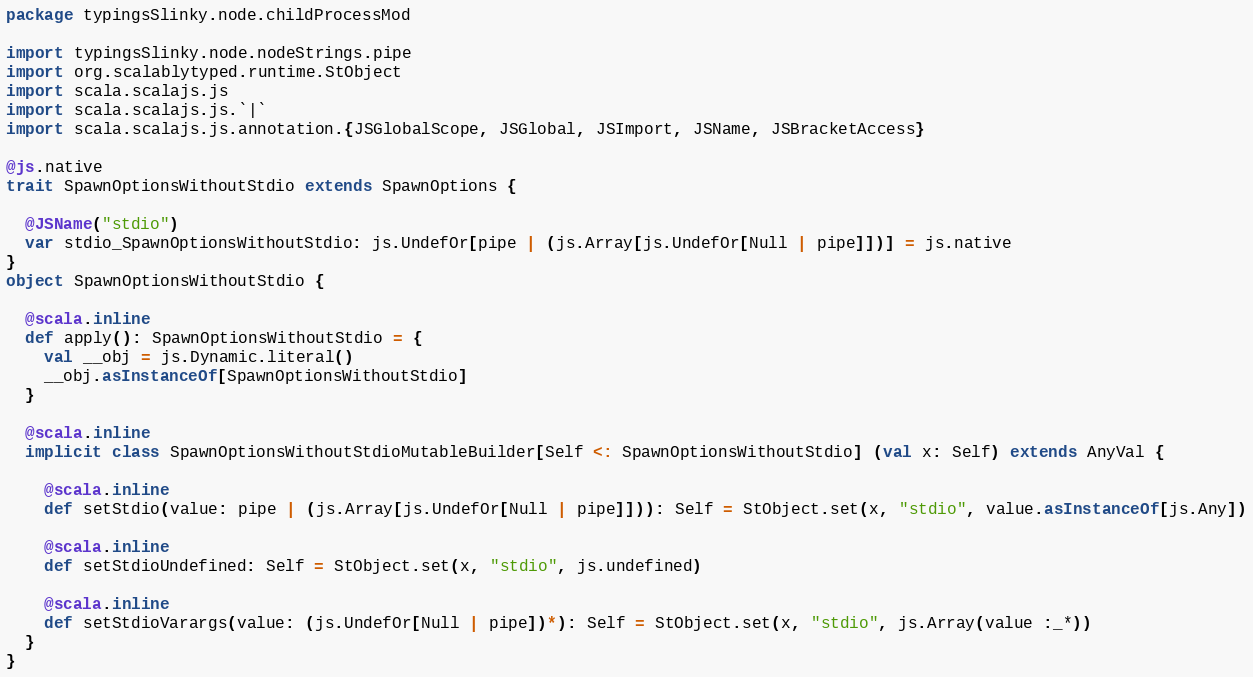<code> <loc_0><loc_0><loc_500><loc_500><_Scala_>package typingsSlinky.node.childProcessMod

import typingsSlinky.node.nodeStrings.pipe
import org.scalablytyped.runtime.StObject
import scala.scalajs.js
import scala.scalajs.js.`|`
import scala.scalajs.js.annotation.{JSGlobalScope, JSGlobal, JSImport, JSName, JSBracketAccess}

@js.native
trait SpawnOptionsWithoutStdio extends SpawnOptions {
  
  @JSName("stdio")
  var stdio_SpawnOptionsWithoutStdio: js.UndefOr[pipe | (js.Array[js.UndefOr[Null | pipe]])] = js.native
}
object SpawnOptionsWithoutStdio {
  
  @scala.inline
  def apply(): SpawnOptionsWithoutStdio = {
    val __obj = js.Dynamic.literal()
    __obj.asInstanceOf[SpawnOptionsWithoutStdio]
  }
  
  @scala.inline
  implicit class SpawnOptionsWithoutStdioMutableBuilder[Self <: SpawnOptionsWithoutStdio] (val x: Self) extends AnyVal {
    
    @scala.inline
    def setStdio(value: pipe | (js.Array[js.UndefOr[Null | pipe]])): Self = StObject.set(x, "stdio", value.asInstanceOf[js.Any])
    
    @scala.inline
    def setStdioUndefined: Self = StObject.set(x, "stdio", js.undefined)
    
    @scala.inline
    def setStdioVarargs(value: (js.UndefOr[Null | pipe])*): Self = StObject.set(x, "stdio", js.Array(value :_*))
  }
}
</code> 